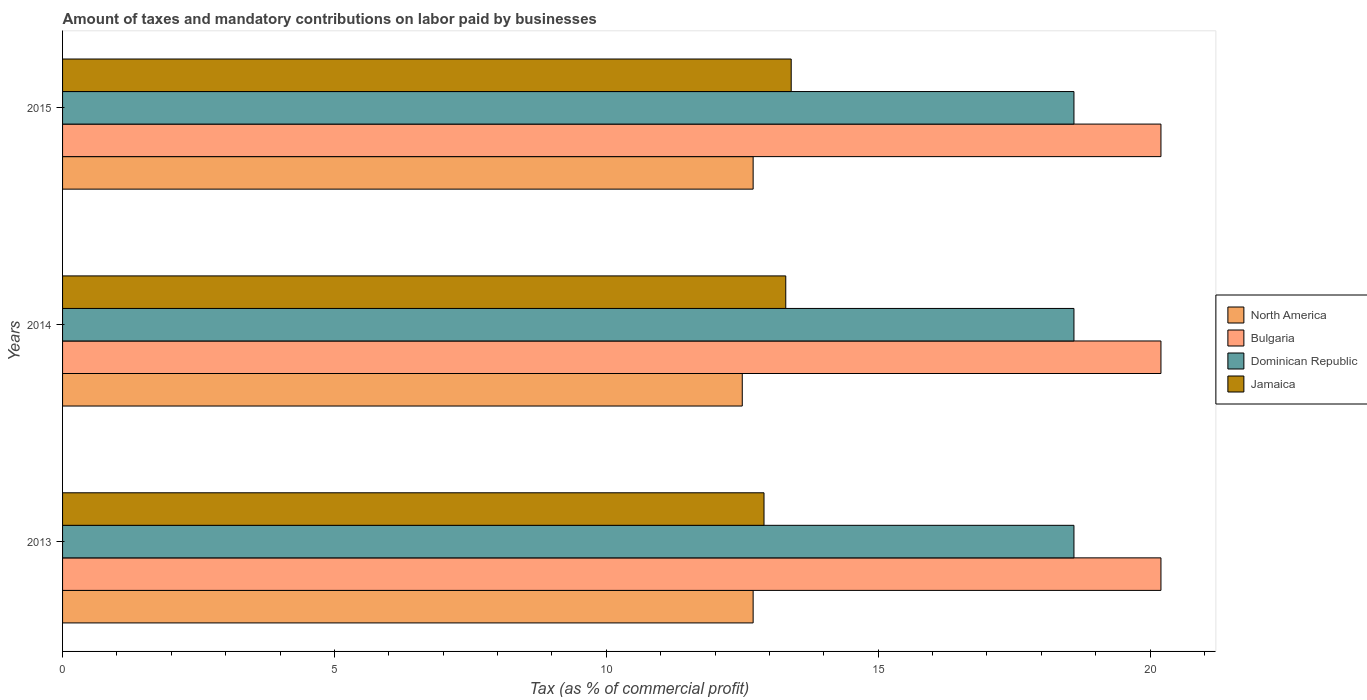In how many cases, is the number of bars for a given year not equal to the number of legend labels?
Provide a succinct answer. 0. What is the percentage of taxes paid by businesses in Jamaica in 2015?
Ensure brevity in your answer.  13.4. Across all years, what is the maximum percentage of taxes paid by businesses in Bulgaria?
Provide a short and direct response. 20.2. Across all years, what is the minimum percentage of taxes paid by businesses in North America?
Make the answer very short. 12.5. In which year was the percentage of taxes paid by businesses in Jamaica maximum?
Your answer should be compact. 2015. In which year was the percentage of taxes paid by businesses in North America minimum?
Provide a succinct answer. 2014. What is the total percentage of taxes paid by businesses in Bulgaria in the graph?
Provide a succinct answer. 60.6. What is the difference between the percentage of taxes paid by businesses in North America in 2013 and that in 2015?
Your answer should be very brief. 0. What is the difference between the percentage of taxes paid by businesses in North America in 2014 and the percentage of taxes paid by businesses in Dominican Republic in 2015?
Your answer should be compact. -6.1. What is the average percentage of taxes paid by businesses in Dominican Republic per year?
Your response must be concise. 18.6. In the year 2013, what is the difference between the percentage of taxes paid by businesses in Bulgaria and percentage of taxes paid by businesses in Jamaica?
Your response must be concise. 7.3. In how many years, is the percentage of taxes paid by businesses in Bulgaria greater than 16 %?
Keep it short and to the point. 3. What is the ratio of the percentage of taxes paid by businesses in Jamaica in 2013 to that in 2014?
Provide a short and direct response. 0.97. Is the difference between the percentage of taxes paid by businesses in Bulgaria in 2013 and 2014 greater than the difference between the percentage of taxes paid by businesses in Jamaica in 2013 and 2014?
Ensure brevity in your answer.  Yes. What is the difference between the highest and the second highest percentage of taxes paid by businesses in Dominican Republic?
Your response must be concise. 0. What is the difference between the highest and the lowest percentage of taxes paid by businesses in North America?
Provide a short and direct response. 0.2. What does the 2nd bar from the top in 2014 represents?
Ensure brevity in your answer.  Dominican Republic. What does the 1st bar from the bottom in 2013 represents?
Keep it short and to the point. North America. Is it the case that in every year, the sum of the percentage of taxes paid by businesses in Dominican Republic and percentage of taxes paid by businesses in Jamaica is greater than the percentage of taxes paid by businesses in North America?
Keep it short and to the point. Yes. Are all the bars in the graph horizontal?
Give a very brief answer. Yes. How many years are there in the graph?
Your answer should be compact. 3. Are the values on the major ticks of X-axis written in scientific E-notation?
Your answer should be very brief. No. Does the graph contain any zero values?
Offer a terse response. No. Where does the legend appear in the graph?
Your answer should be compact. Center right. What is the title of the graph?
Provide a succinct answer. Amount of taxes and mandatory contributions on labor paid by businesses. What is the label or title of the X-axis?
Your answer should be compact. Tax (as % of commercial profit). What is the label or title of the Y-axis?
Make the answer very short. Years. What is the Tax (as % of commercial profit) of North America in 2013?
Provide a succinct answer. 12.7. What is the Tax (as % of commercial profit) of Bulgaria in 2013?
Offer a terse response. 20.2. What is the Tax (as % of commercial profit) of North America in 2014?
Provide a short and direct response. 12.5. What is the Tax (as % of commercial profit) in Bulgaria in 2014?
Your answer should be very brief. 20.2. What is the Tax (as % of commercial profit) in North America in 2015?
Your answer should be compact. 12.7. What is the Tax (as % of commercial profit) in Bulgaria in 2015?
Keep it short and to the point. 20.2. What is the Tax (as % of commercial profit) in Jamaica in 2015?
Your response must be concise. 13.4. Across all years, what is the maximum Tax (as % of commercial profit) of Bulgaria?
Offer a terse response. 20.2. Across all years, what is the minimum Tax (as % of commercial profit) in North America?
Keep it short and to the point. 12.5. Across all years, what is the minimum Tax (as % of commercial profit) of Bulgaria?
Provide a succinct answer. 20.2. Across all years, what is the minimum Tax (as % of commercial profit) of Dominican Republic?
Give a very brief answer. 18.6. Across all years, what is the minimum Tax (as % of commercial profit) in Jamaica?
Your response must be concise. 12.9. What is the total Tax (as % of commercial profit) of North America in the graph?
Keep it short and to the point. 37.9. What is the total Tax (as % of commercial profit) of Bulgaria in the graph?
Offer a terse response. 60.6. What is the total Tax (as % of commercial profit) in Dominican Republic in the graph?
Provide a succinct answer. 55.8. What is the total Tax (as % of commercial profit) of Jamaica in the graph?
Give a very brief answer. 39.6. What is the difference between the Tax (as % of commercial profit) of North America in 2013 and that in 2014?
Your answer should be compact. 0.2. What is the difference between the Tax (as % of commercial profit) of Bulgaria in 2013 and that in 2014?
Make the answer very short. 0. What is the difference between the Tax (as % of commercial profit) in North America in 2013 and that in 2015?
Offer a very short reply. 0. What is the difference between the Tax (as % of commercial profit) in Dominican Republic in 2013 and that in 2015?
Offer a very short reply. 0. What is the difference between the Tax (as % of commercial profit) of Jamaica in 2013 and that in 2015?
Give a very brief answer. -0.5. What is the difference between the Tax (as % of commercial profit) in North America in 2014 and that in 2015?
Your response must be concise. -0.2. What is the difference between the Tax (as % of commercial profit) of Dominican Republic in 2014 and that in 2015?
Your answer should be compact. 0. What is the difference between the Tax (as % of commercial profit) of Bulgaria in 2013 and the Tax (as % of commercial profit) of Jamaica in 2014?
Your answer should be compact. 6.9. What is the difference between the Tax (as % of commercial profit) of Dominican Republic in 2013 and the Tax (as % of commercial profit) of Jamaica in 2014?
Your answer should be very brief. 5.3. What is the difference between the Tax (as % of commercial profit) in Bulgaria in 2013 and the Tax (as % of commercial profit) in Dominican Republic in 2015?
Provide a succinct answer. 1.6. What is the difference between the Tax (as % of commercial profit) of Bulgaria in 2013 and the Tax (as % of commercial profit) of Jamaica in 2015?
Give a very brief answer. 6.8. What is the difference between the Tax (as % of commercial profit) of North America in 2014 and the Tax (as % of commercial profit) of Jamaica in 2015?
Your answer should be compact. -0.9. What is the difference between the Tax (as % of commercial profit) in Bulgaria in 2014 and the Tax (as % of commercial profit) in Dominican Republic in 2015?
Give a very brief answer. 1.6. What is the difference between the Tax (as % of commercial profit) of Bulgaria in 2014 and the Tax (as % of commercial profit) of Jamaica in 2015?
Offer a terse response. 6.8. What is the difference between the Tax (as % of commercial profit) in Dominican Republic in 2014 and the Tax (as % of commercial profit) in Jamaica in 2015?
Keep it short and to the point. 5.2. What is the average Tax (as % of commercial profit) in North America per year?
Ensure brevity in your answer.  12.63. What is the average Tax (as % of commercial profit) of Bulgaria per year?
Ensure brevity in your answer.  20.2. What is the average Tax (as % of commercial profit) of Jamaica per year?
Keep it short and to the point. 13.2. In the year 2013, what is the difference between the Tax (as % of commercial profit) in North America and Tax (as % of commercial profit) in Bulgaria?
Your answer should be compact. -7.5. In the year 2013, what is the difference between the Tax (as % of commercial profit) of North America and Tax (as % of commercial profit) of Dominican Republic?
Your response must be concise. -5.9. In the year 2013, what is the difference between the Tax (as % of commercial profit) in Bulgaria and Tax (as % of commercial profit) in Dominican Republic?
Keep it short and to the point. 1.6. In the year 2013, what is the difference between the Tax (as % of commercial profit) of Bulgaria and Tax (as % of commercial profit) of Jamaica?
Provide a short and direct response. 7.3. In the year 2014, what is the difference between the Tax (as % of commercial profit) of North America and Tax (as % of commercial profit) of Jamaica?
Keep it short and to the point. -0.8. In the year 2014, what is the difference between the Tax (as % of commercial profit) of Dominican Republic and Tax (as % of commercial profit) of Jamaica?
Offer a terse response. 5.3. In the year 2015, what is the difference between the Tax (as % of commercial profit) of North America and Tax (as % of commercial profit) of Jamaica?
Your answer should be compact. -0.7. In the year 2015, what is the difference between the Tax (as % of commercial profit) in Bulgaria and Tax (as % of commercial profit) in Jamaica?
Offer a terse response. 6.8. In the year 2015, what is the difference between the Tax (as % of commercial profit) of Dominican Republic and Tax (as % of commercial profit) of Jamaica?
Make the answer very short. 5.2. What is the ratio of the Tax (as % of commercial profit) of North America in 2013 to that in 2014?
Your answer should be compact. 1.02. What is the ratio of the Tax (as % of commercial profit) in Bulgaria in 2013 to that in 2014?
Offer a terse response. 1. What is the ratio of the Tax (as % of commercial profit) of Jamaica in 2013 to that in 2014?
Make the answer very short. 0.97. What is the ratio of the Tax (as % of commercial profit) in Jamaica in 2013 to that in 2015?
Make the answer very short. 0.96. What is the ratio of the Tax (as % of commercial profit) in North America in 2014 to that in 2015?
Offer a very short reply. 0.98. What is the ratio of the Tax (as % of commercial profit) of Dominican Republic in 2014 to that in 2015?
Your answer should be very brief. 1. What is the difference between the highest and the second highest Tax (as % of commercial profit) of Dominican Republic?
Offer a very short reply. 0. What is the difference between the highest and the second highest Tax (as % of commercial profit) in Jamaica?
Provide a short and direct response. 0.1. What is the difference between the highest and the lowest Tax (as % of commercial profit) of North America?
Make the answer very short. 0.2. What is the difference between the highest and the lowest Tax (as % of commercial profit) of Bulgaria?
Ensure brevity in your answer.  0. What is the difference between the highest and the lowest Tax (as % of commercial profit) of Dominican Republic?
Your answer should be compact. 0. What is the difference between the highest and the lowest Tax (as % of commercial profit) in Jamaica?
Give a very brief answer. 0.5. 